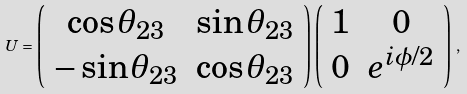Convert formula to latex. <formula><loc_0><loc_0><loc_500><loc_500>U = \left ( \begin{array} { c c } \cos \theta _ { 2 3 } & \sin \theta _ { 2 3 } \\ - \sin \theta _ { 2 3 } & \cos \theta _ { 2 3 } \end{array} \right ) \left ( \begin{array} { c c } 1 & 0 \\ 0 & e ^ { i \phi / 2 } \end{array} \right ) \, ,</formula> 